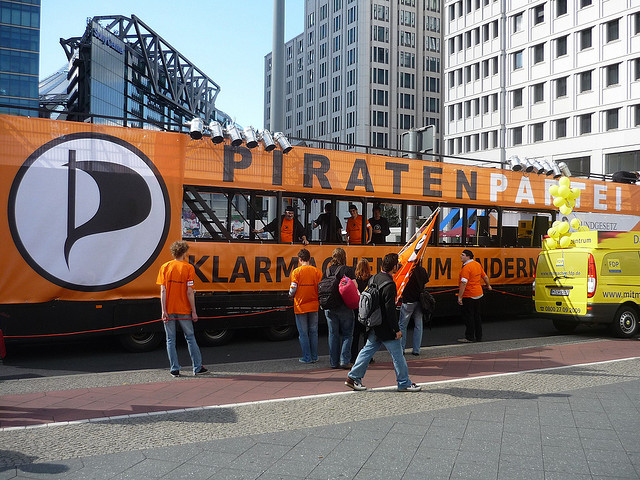Please transcribe the text in this image. PIRATEN KLARM NDERN 